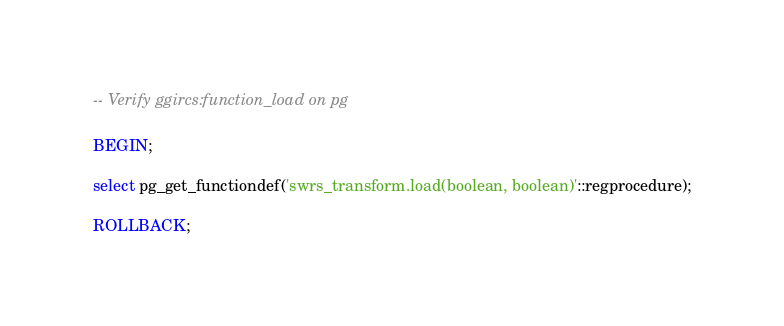<code> <loc_0><loc_0><loc_500><loc_500><_SQL_>-- Verify ggircs:function_load on pg

BEGIN;

select pg_get_functiondef('swrs_transform.load(boolean, boolean)'::regprocedure);

ROLLBACK;
</code> 